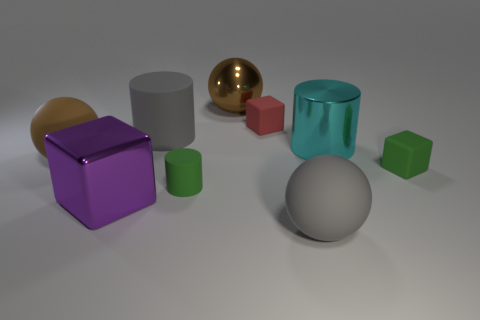The gray rubber thing that is the same shape as the cyan thing is what size?
Offer a very short reply. Large. Is the number of rubber cubes that are on the right side of the tiny cylinder greater than the number of big blocks?
Offer a terse response. Yes. Do the large gray thing that is on the right side of the red matte object and the red object have the same material?
Your response must be concise. Yes. What size is the gray matte object right of the matte object behind the big gray cylinder that is in front of the small red block?
Your answer should be compact. Large. The red thing that is made of the same material as the small green cylinder is what size?
Your response must be concise. Small. There is a big shiny thing that is on the left side of the tiny red matte object and right of the gray rubber cylinder; what is its color?
Ensure brevity in your answer.  Brown. Is the shape of the big metallic thing behind the large cyan shiny cylinder the same as the object that is in front of the purple thing?
Make the answer very short. Yes. There is a cylinder on the right side of the tiny matte cylinder; what material is it?
Offer a very short reply. Metal. What size is the ball that is the same color as the big rubber cylinder?
Provide a succinct answer. Large. How many objects are metal objects right of the purple object or tiny purple objects?
Your response must be concise. 2. 